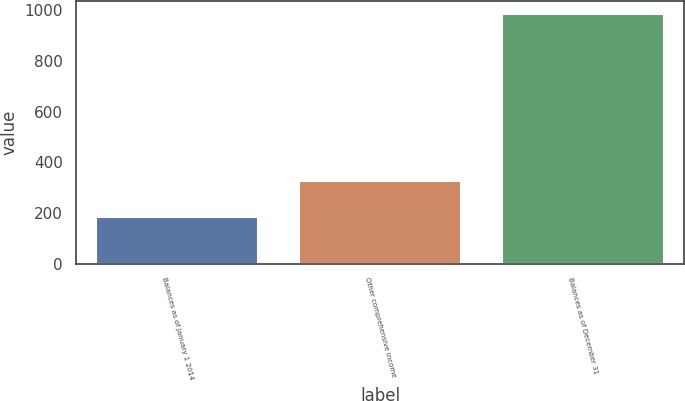<chart> <loc_0><loc_0><loc_500><loc_500><bar_chart><fcel>Balances as of January 1 2014<fcel>Other comprehensive income<fcel>Balances as of December 31<nl><fcel>185<fcel>326<fcel>985<nl></chart> 